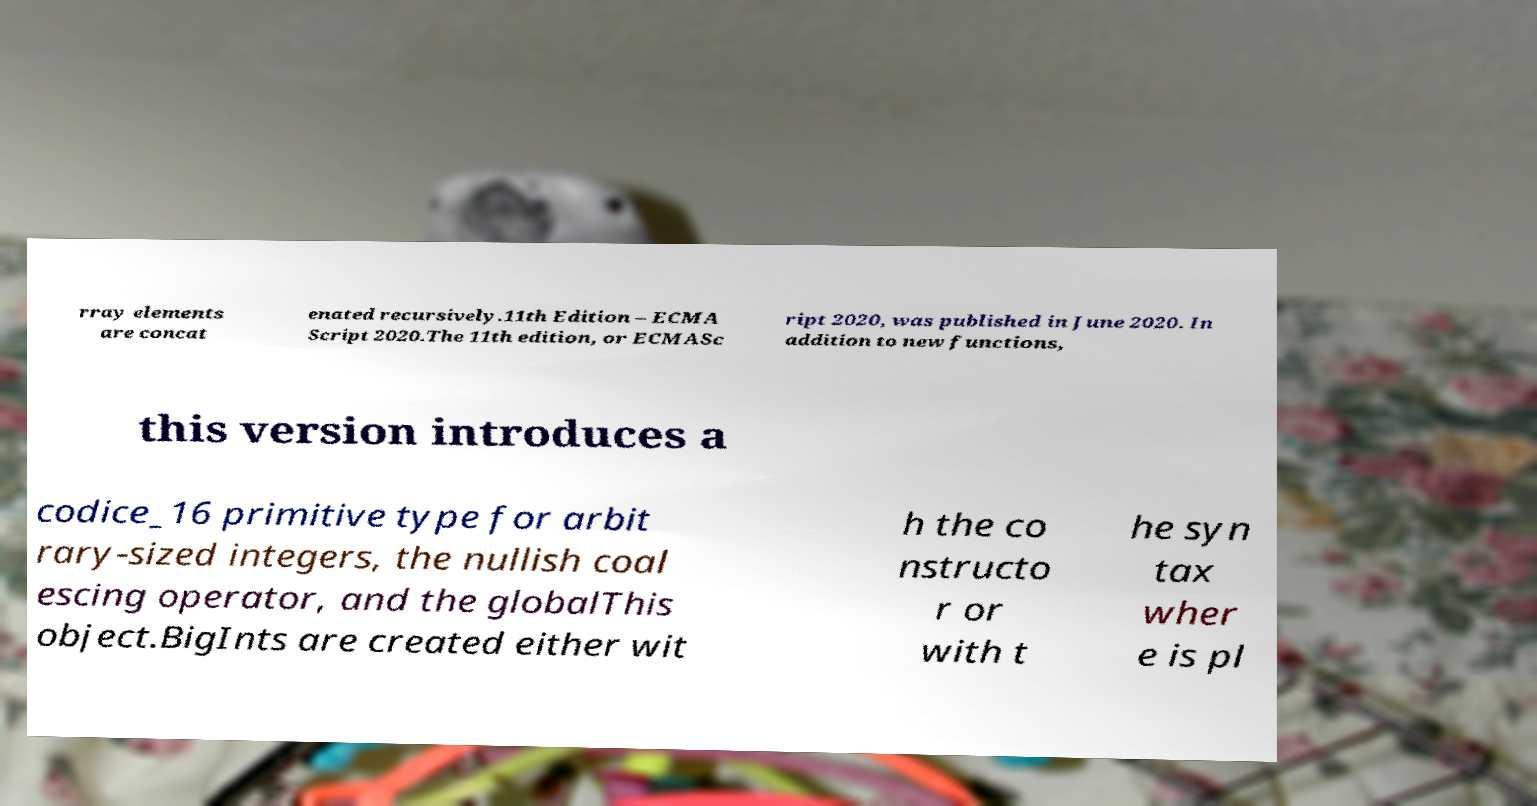Can you accurately transcribe the text from the provided image for me? rray elements are concat enated recursively.11th Edition – ECMA Script 2020.The 11th edition, or ECMASc ript 2020, was published in June 2020. In addition to new functions, this version introduces a codice_16 primitive type for arbit rary-sized integers, the nullish coal escing operator, and the globalThis object.BigInts are created either wit h the co nstructo r or with t he syn tax wher e is pl 